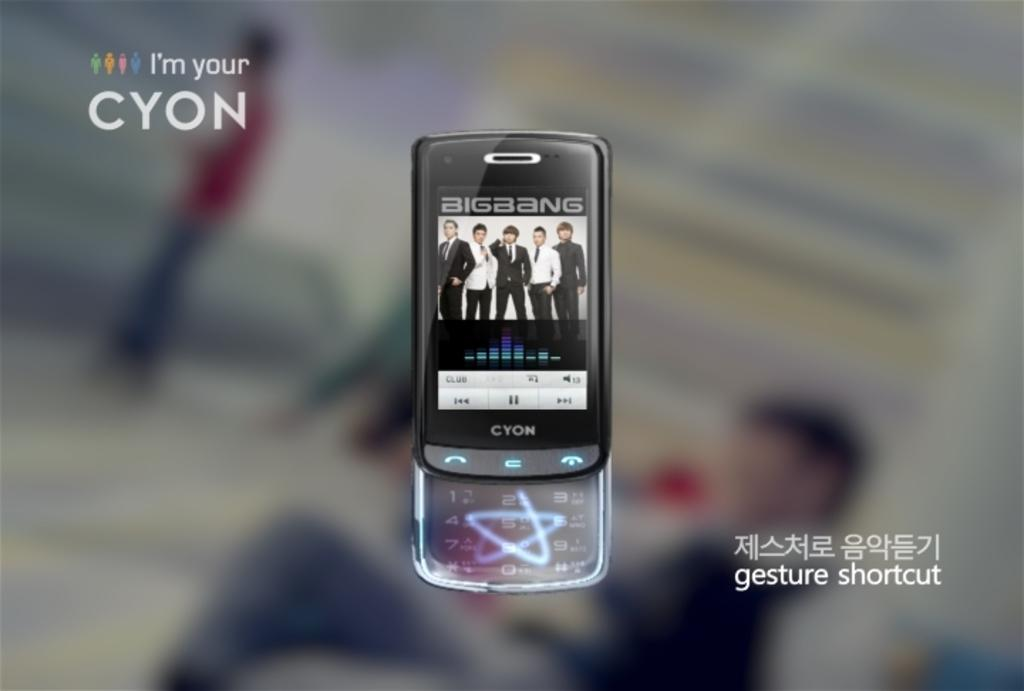What can be observed about the nature of the image? The image is edited. What is the main object in the middle of the image? There is a mobile in the middle of the image. What is featured on the mobile? The mobile contains pictures and has a keyboard. Where can text be found in the image? There is text on the right side of the image. What type of quartz is present on the mobile? There is no quartz present on the mobile or in the image. 